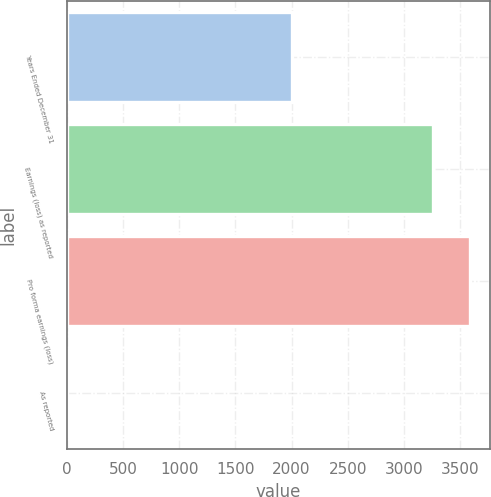<chart> <loc_0><loc_0><loc_500><loc_500><bar_chart><fcel>Years Ended December 31<fcel>Earnings (loss) as reported<fcel>Pro forma earnings (loss)<fcel>As reported<nl><fcel>2006<fcel>3261<fcel>3586.97<fcel>1.33<nl></chart> 